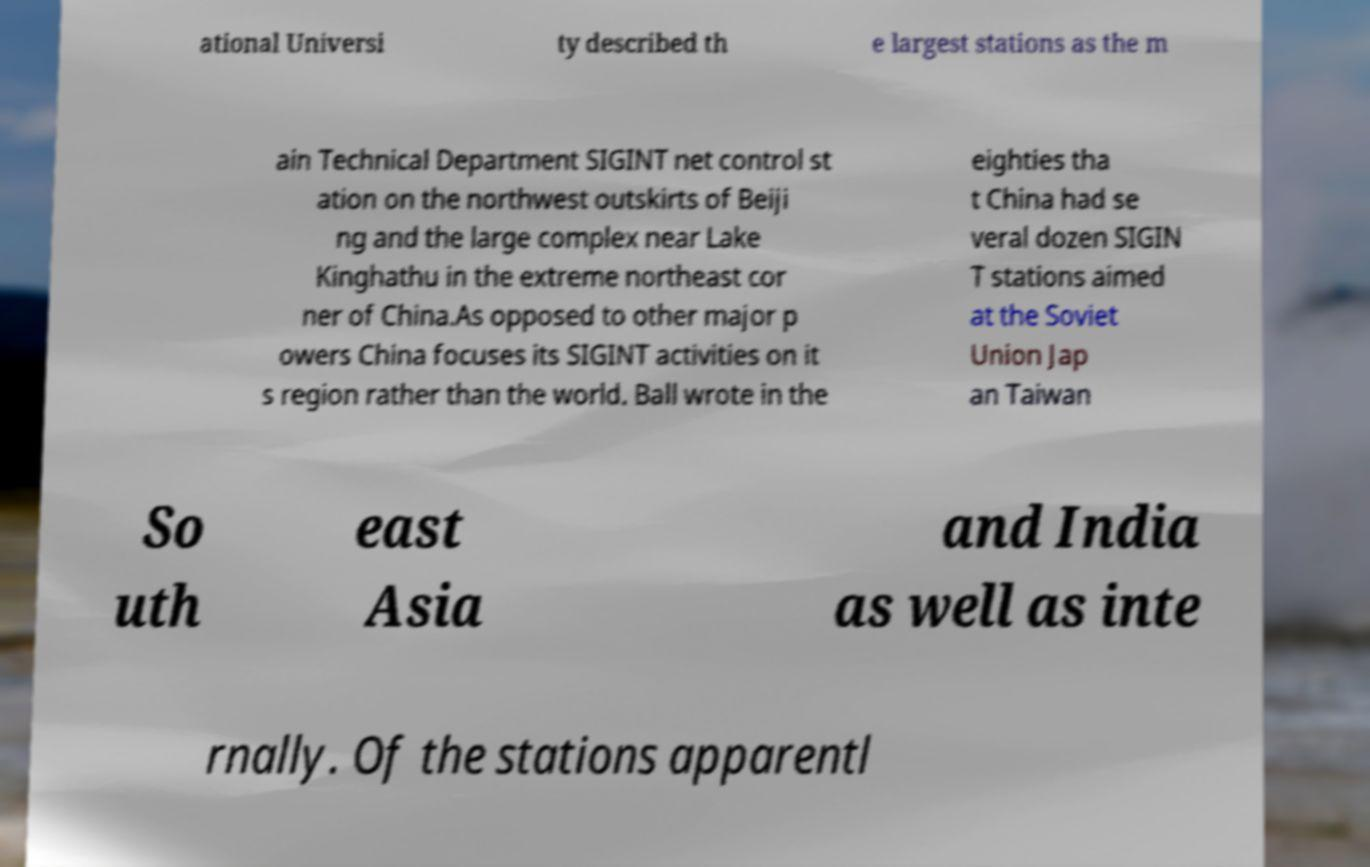Could you extract and type out the text from this image? ational Universi ty described th e largest stations as the m ain Technical Department SIGINT net control st ation on the northwest outskirts of Beiji ng and the large complex near Lake Kinghathu in the extreme northeast cor ner of China.As opposed to other major p owers China focuses its SIGINT activities on it s region rather than the world. Ball wrote in the eighties tha t China had se veral dozen SIGIN T stations aimed at the Soviet Union Jap an Taiwan So uth east Asia and India as well as inte rnally. Of the stations apparentl 